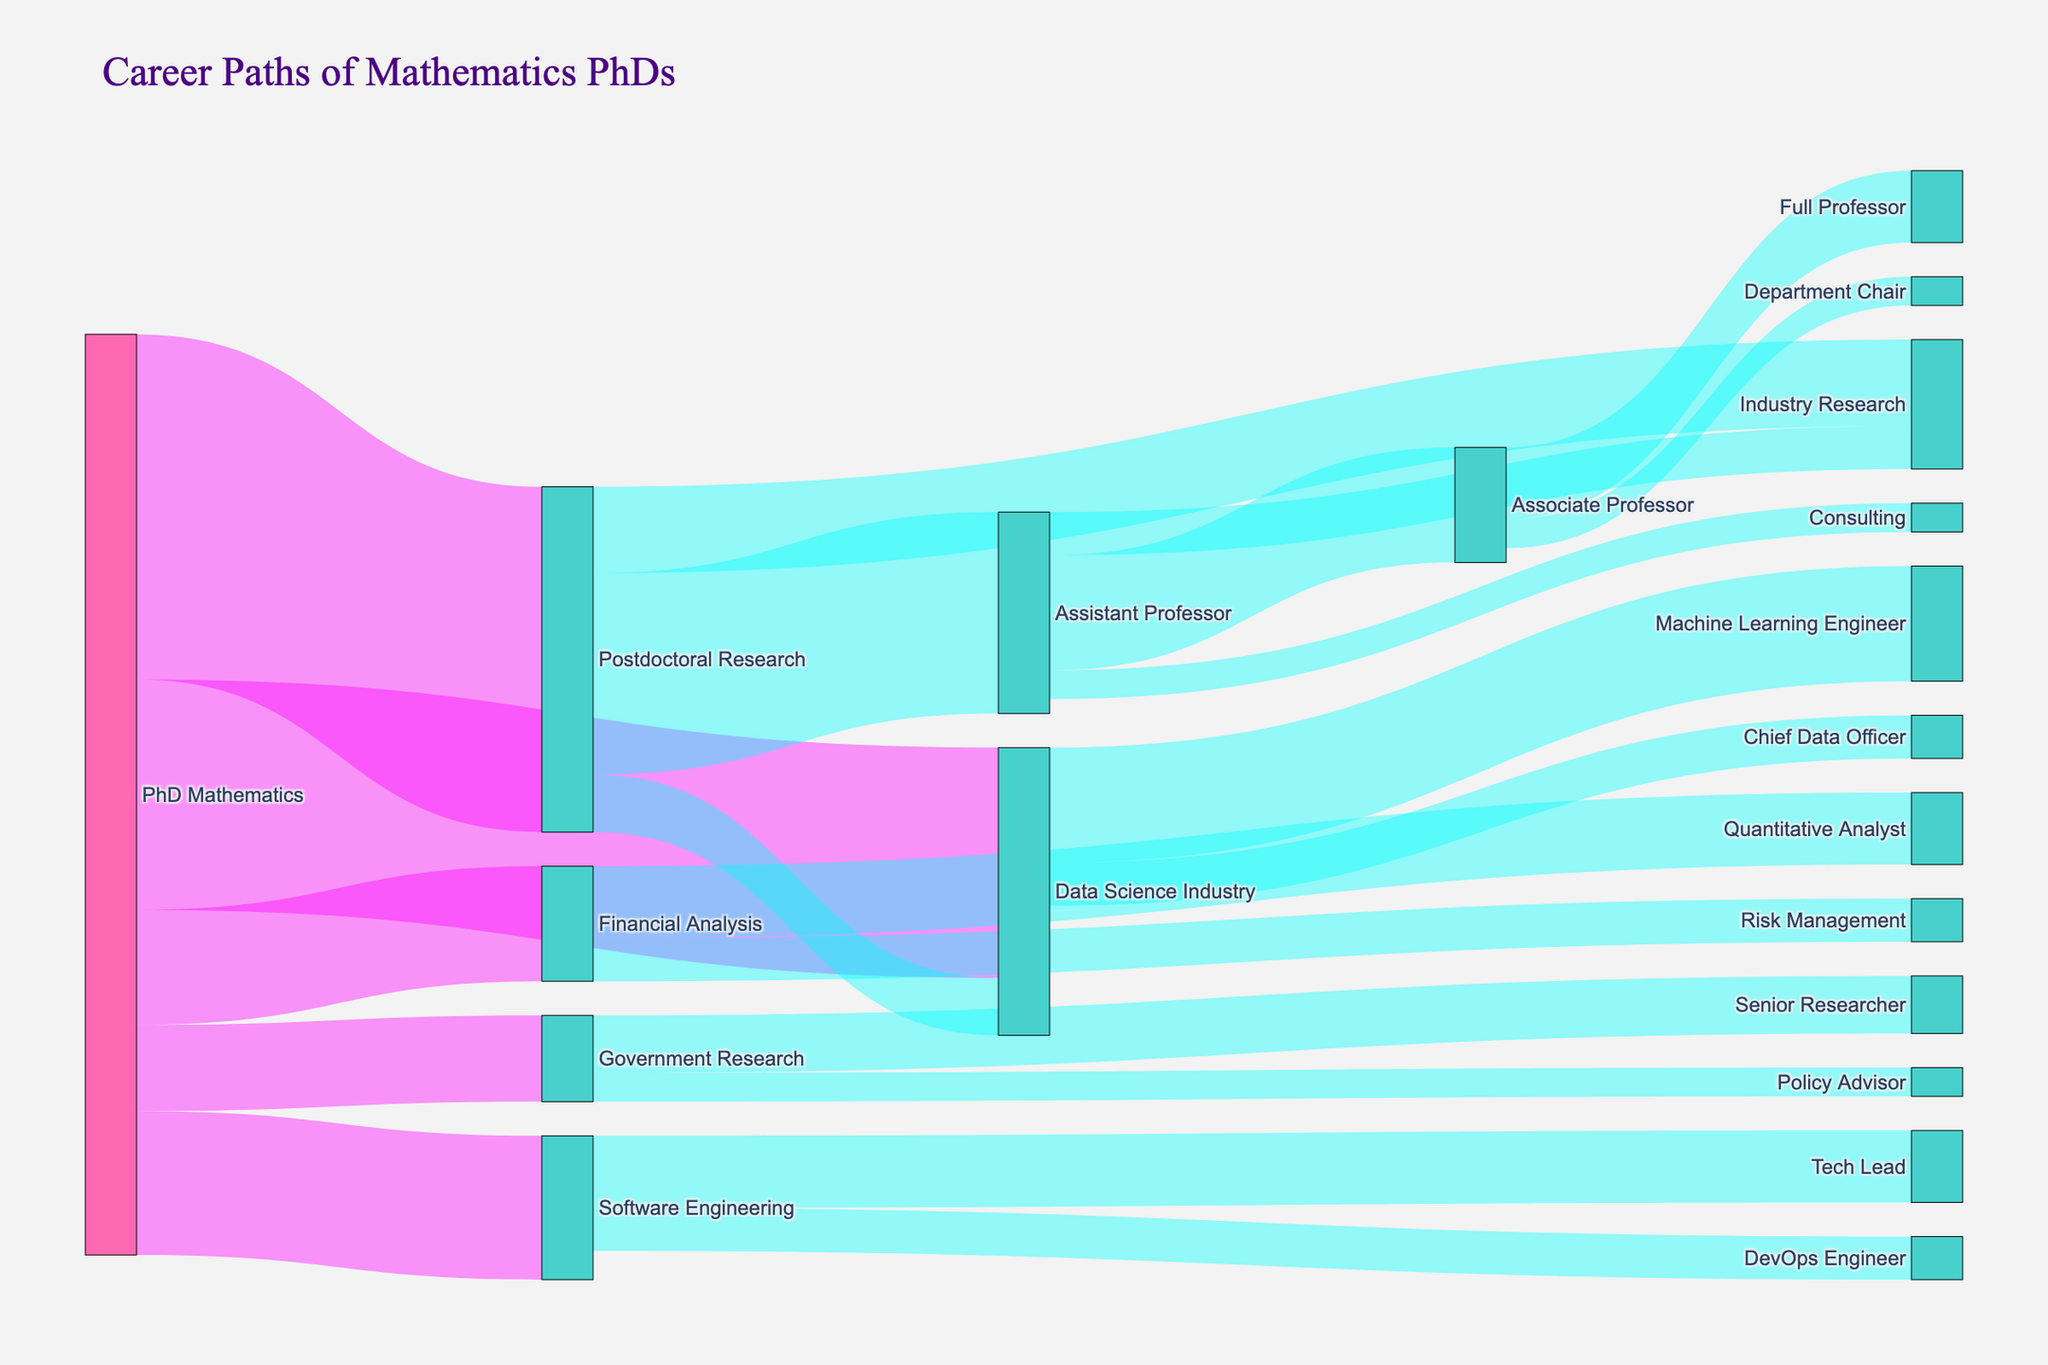what is the title of the figure? The title is usually found at the top of the diagram in a larger or bold font. In this figure, it is clearly written at the top.
Answer: Career Paths of Mathematics PhDs What are the different initial career paths available for Mathematics PhDs according to the diagram? By looking at the source nodes directly connected from "PhD Mathematics", we can see the initial career paths available.
Answer: Postdoctoral Research, Data Science Industry, Software Engineering, Financial Analysis, Government Research How many Mathematics PhDs transitioned into Data Science Industry right after their PhD? The figure shows the values next to the links representing transitions. Looking at the link from "PhD Mathematics" to "Data Science Industry", we find the number.
Answer: 80 Which career path has the highest transition value from Postdoctoral Research? By comparing the values of links from "Postdoctoral Research" to other nodes, we see that the highest value is 70 to "Assistant Professor".
Answer: Assistant Professor What is the difference in the number of Math PhDs moving from Postdoctoral Research to Assistant Professor and those moving to Industry Research? We look at the values of transitions. From Postdoctoral Research to Assistant Professor is 70, and to Industry Research is 30. Subtracting these gives the difference.
Answer: 40 How many Mathematics PhDs transitioned to roles in Government Research right after their PhD? Check the link value from "PhD Mathematics" to "Government Research".
Answer: 30 Which transition has the smallest value, and what is it? By comparing each link value, the smallest value is from "Assistant Professor" to "Consulting" with a value of 10.
Answer: Assistant Professor to Consulting, 10 What proportion of Mathematics PhDs went into Postdoctoral Research versus Data Science Industry? Add the values of transitions from "PhD Mathematics" and calculate the proportion for Postdoctoral Research (120) and Data Science Industry (80). Total is 320. Proportion is calculated as value/total.
Answer: Postdoctoral Research: 120/320 = 0.375, Data Science Industry: 80/320 = 0.25 Which academic role has more transitions, Assistant Professor to Associate Professor or Associate Professor to Full Professor? Comparing the two link values, 40 for Assistant to Associate Professor, and 25 for Associate to Full Professor, the answer is clear.
Answer: Assistant Professor to Associate Professor, 40 What secondary career path within academia is accessible to someone who was a Mathematics PhD? Follow the links from PhD Mathematics to Postdoctoral Research and then from Postdoctoral Research to see paths such as Assistant Professor, and continuing to Associate Professor and Full Professor.
Answer: Assistant Professor, Associate Professor, Full Professor 